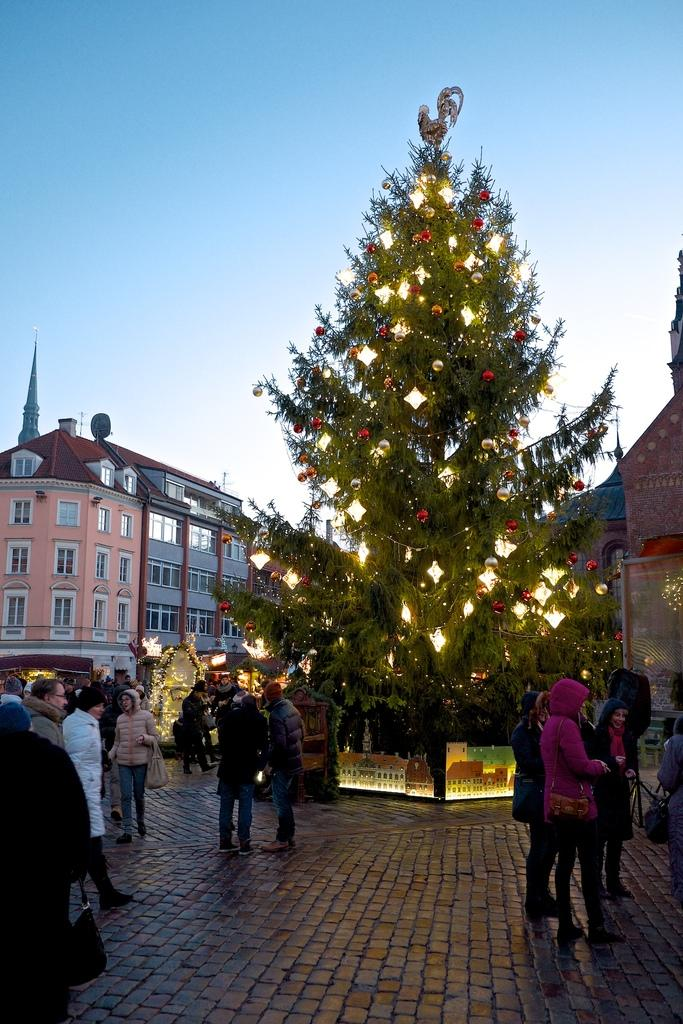What is the main object in the image? There is a tree in the image. How is the tree decorated? The tree is decorated with lights and other things. Are there any other people in the image besides the tree? Yes, there are other people in the image. What can be seen in the background of the image? There are buildings visible in the image. What type of cracker is being used to balance on the tree in the image? There is no cracker present in the image, nor is there any indication of balancing on the tree. 